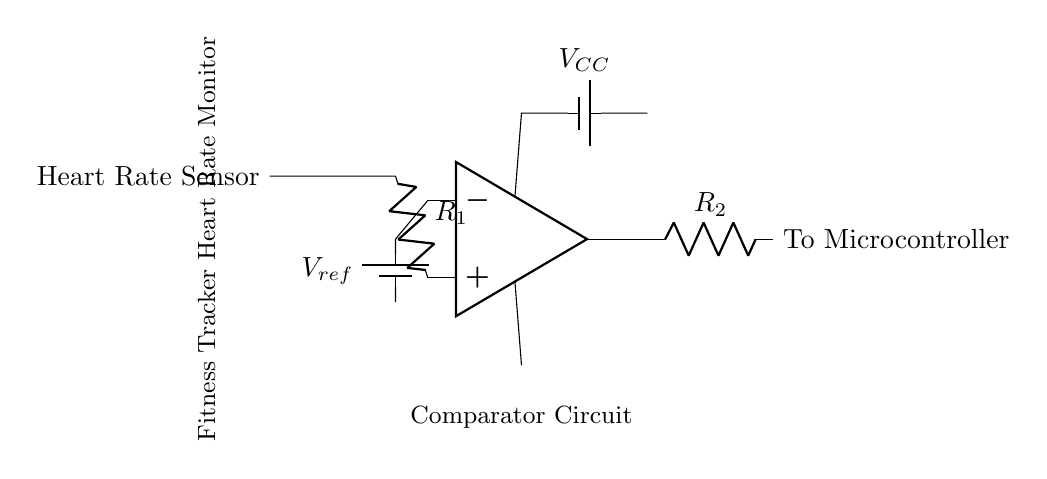What type of circuit is this? This circuit is a comparator circuit since it uses an operational amplifier to compare the voltage from the heart rate sensor with a reference voltage. The output will indicate whether the heart rate reading is above or below the reference value, which is characteristic of a comparator configuration.
Answer: Comparator circuit What is the function of the heart rate sensor? The heart rate sensor's function is to provide an analog voltage that represents the heart rate. This voltage is fed into the non-inverting input of the operational amplifier to be compared with the reference voltage.
Answer: To provide heart rate voltage What is the reference voltage in this circuit? The reference voltage, noted as Vref, is supplied by a battery in this circuit and acts as a threshold for the comparator. The output of the operational amplifier will change based on whether the sensor voltage is above or below this reference voltage.
Answer: Vref Which component connects to the microcontroller? The output of the operational amplifier connects to the microcontroller, indicated in the diagram as "To Microcontroller." It represents the processed signal that the microcontroller will use for further analysis or action.
Answer: Output of the op-amp What do the resistors R1 and R2 do in this circuit? In this circuit, resistor R1 is used to limit the current coming from the heart rate sensor to the op-amp, while R2 is used to modify the output voltage level from the op-amp before it sends it to the microcontroller. The specific values can affect the behavior of the circuit, enabling proper interfacing.
Answer: R1 limits current, R2 modifies output What happens if the output of the op-amp is high? If the output of the op-amp is high, it indicates that the input voltage from the heart rate sensor is greater than the reference voltage. This would typically signal the microcontroller that the heart rate is above the desired threshold, prompting a corresponding response or alert.
Answer: Input > Vref How does power supply affect this circuit? The power supply, denoted as Vcc, is crucial as it powers the operational amplifier. Without it, the op-amp cannot function, and the circuit will not be able to operate to detect or monitor the heart rate accurately. The power supply must be within the operational limits of the op-amp for proper functionality.
Answer: Powers op-amp 